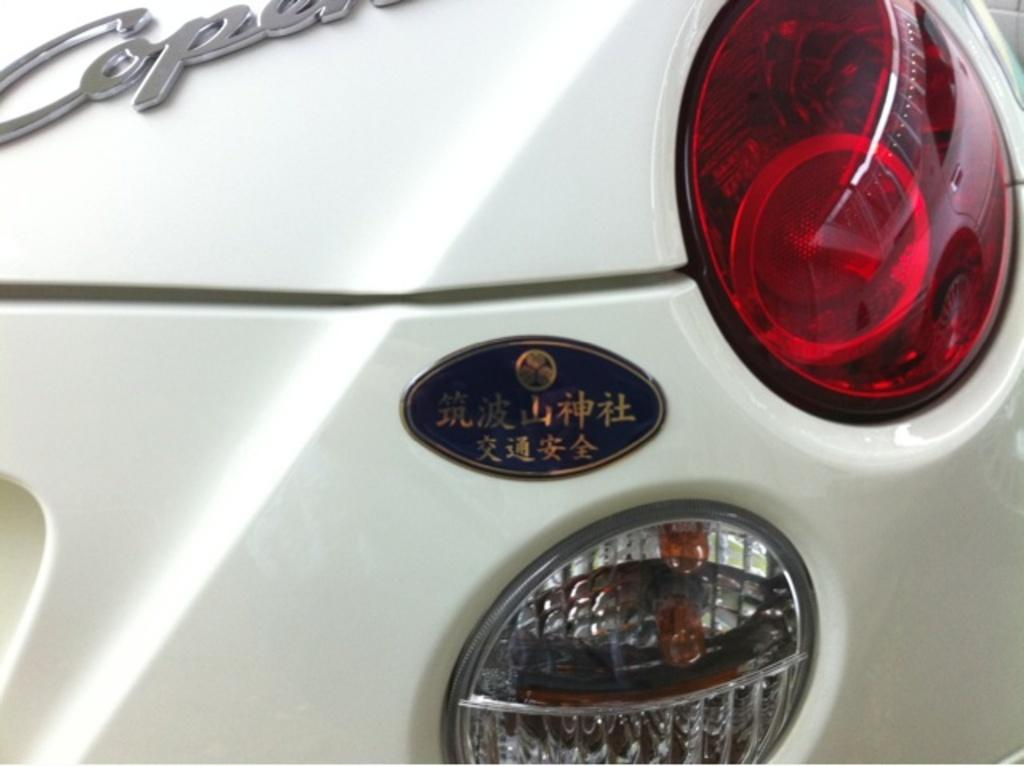What is the main subject of the image? The main subject of the image is a car. Are there any words or letters on the car? Yes, there is text written on the car. What color are the lights on the car? There are lights with yellow color and lights with red color in the image. How does the car express anger in the image? The car does not express anger in the image; it is an inanimate object and cannot have emotions. 